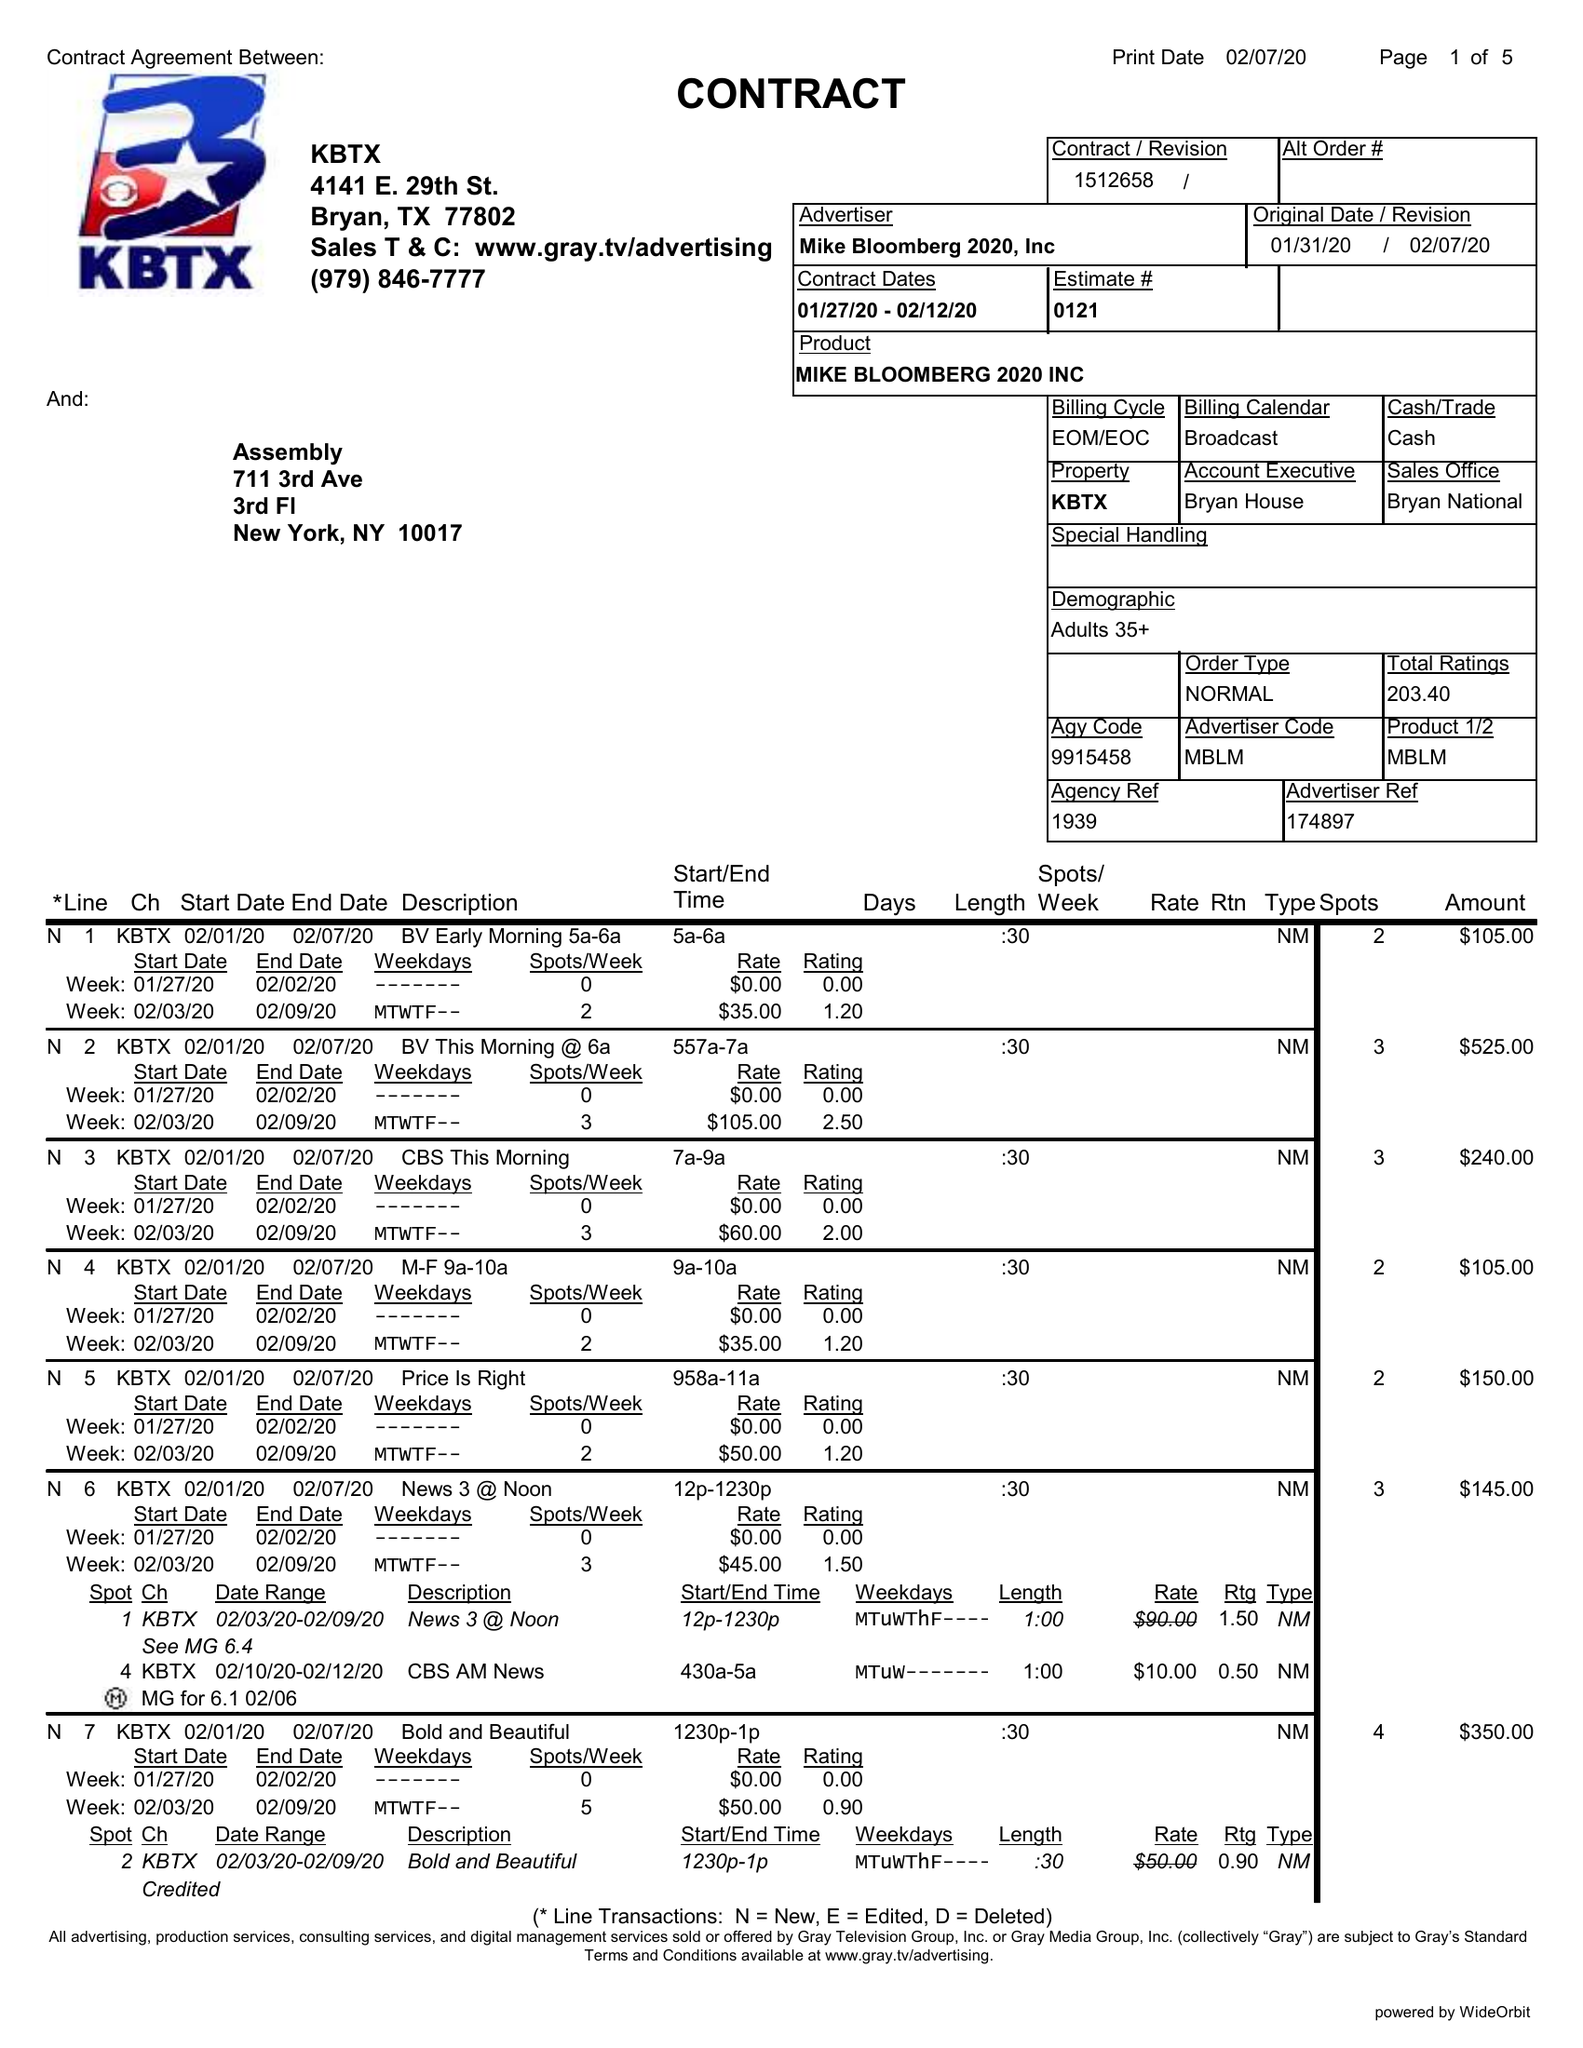What is the value for the advertiser?
Answer the question using a single word or phrase. MIKE BLOOMBERG 2020, INC 